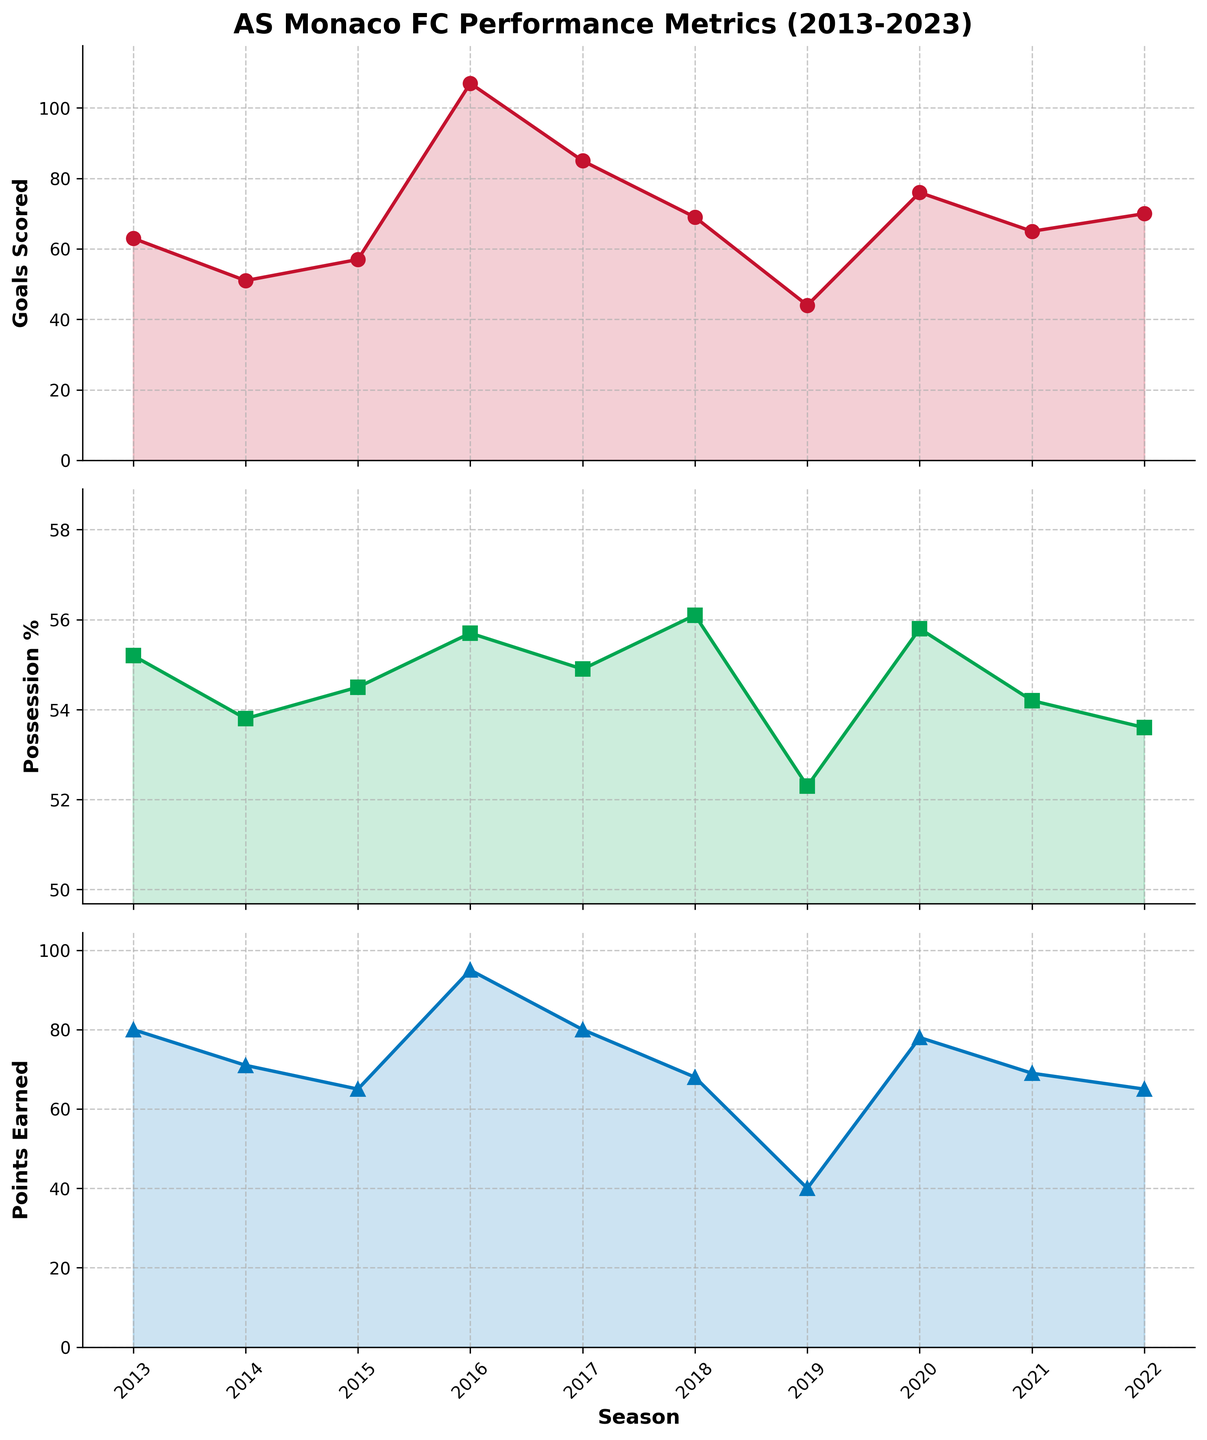What is the highest number of goals scored in a season? Look at the 'Goals Scored' subplot and identify the highest value among the data points. The peak is at 107 goals.
Answer: 107 What was the possession percentage for the 2019-20 season? Check the 'Possession Percentage' subplot for the 2019-20 season. The value is approximately 52.3%.
Answer: 52.3% Which season had the lowest points earned? In the 'Points Earned' subplot, identify the season with the smallest data point. The lowest has 40 points in the 2019-20 season.
Answer: 2019-20 How many seasons had a higher possession percentage than 55%? Count the number of seasons where the data points in the 'Possession Percentage' subplot are above 55%. There are four such seasons (2013-14, 2016-17, 2018-19, and 2020-21).
Answer: 4 What is the difference in goals scored between the 2016-17 and 2019-20 seasons? Find the goals scored in 2016-17 (107) and 2019-20 (44). Subtract the latter from the former: 107 - 44 = 63.
Answer: 63 Did AS Monaco FC have a season with fewer than 50 points earned? Check if there are any data points below 50 in the 'Points Earned' subplot. Yes, the 2019-20 season had 40 points.
Answer: Yes What trends do you notice in the 'Goals Scored' subplot from 2013 to 2023? Look at the overall pattern of the line chart for 'Goals Scored'. The trend shows an initial decrease, a sharp peak in 2016-17, a dip afterward, then a slight recovery.
Answer: Decrease, peak in 2016-17, dip, slight recovery What is the average number of goals scored per season across the decade? Sum the goals scored across all seasons (63 + 51 + 57 + 107 + 85 + 69 + 44 + 76 + 65 + 70 = 687), then divide by the number of seasons (10). The average is 687/10 = 68.7.
Answer: 68.7 